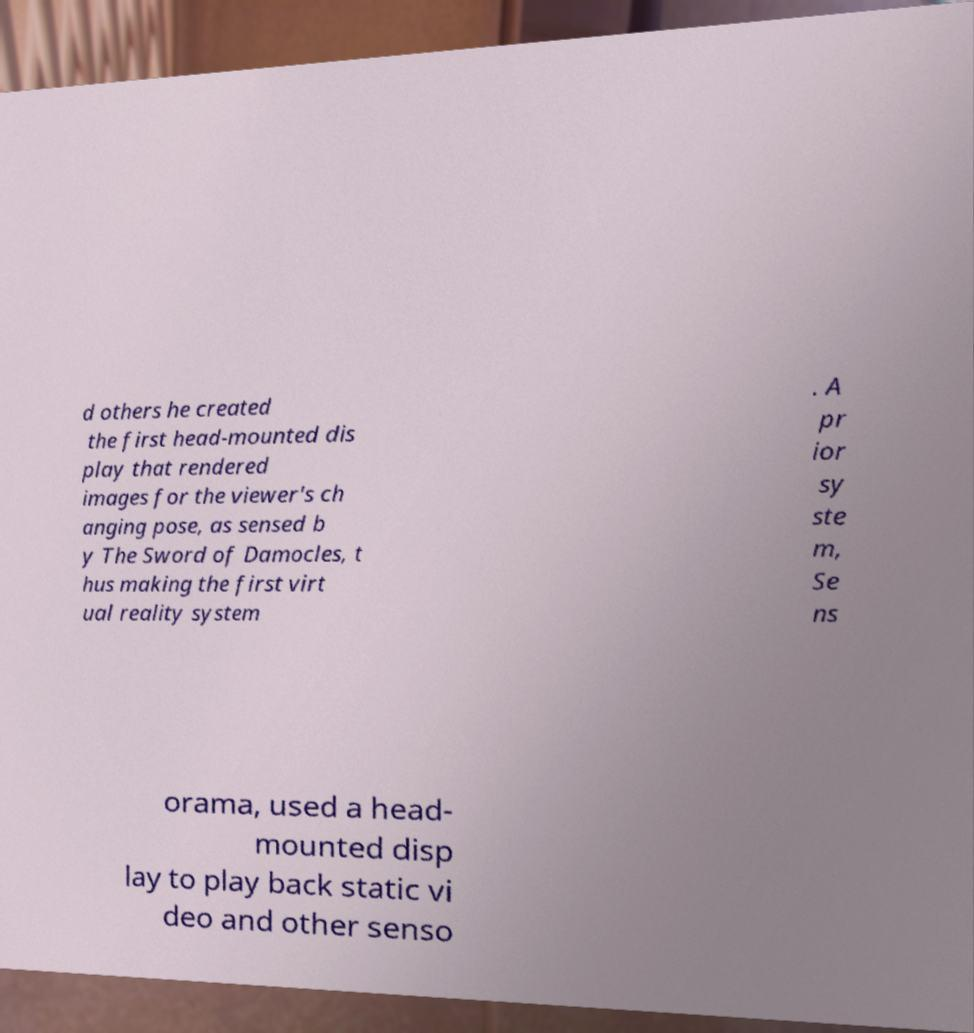What messages or text are displayed in this image? I need them in a readable, typed format. d others he created the first head-mounted dis play that rendered images for the viewer's ch anging pose, as sensed b y The Sword of Damocles, t hus making the first virt ual reality system . A pr ior sy ste m, Se ns orama, used a head- mounted disp lay to play back static vi deo and other senso 